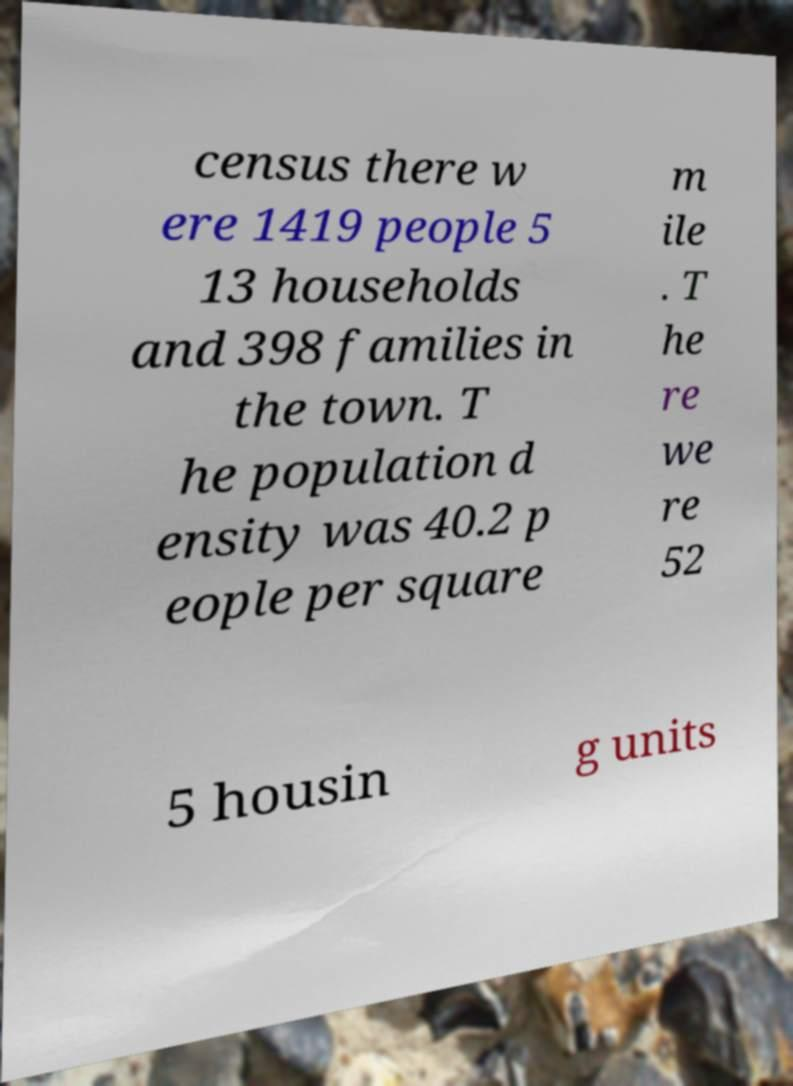Please identify and transcribe the text found in this image. census there w ere 1419 people 5 13 households and 398 families in the town. T he population d ensity was 40.2 p eople per square m ile . T he re we re 52 5 housin g units 